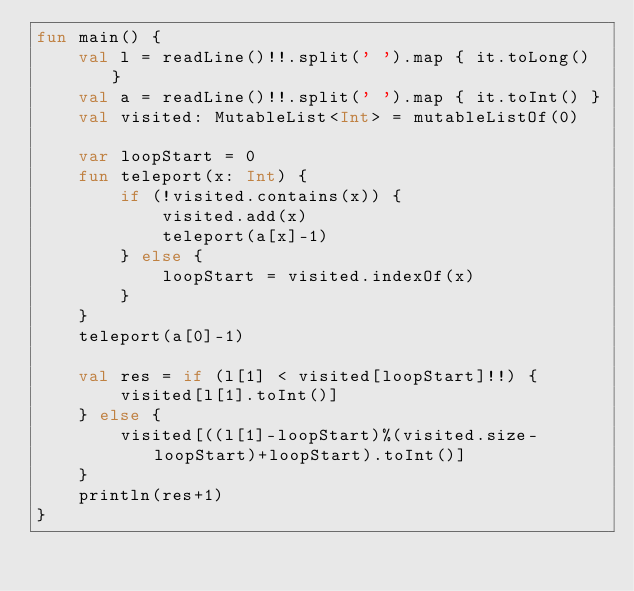<code> <loc_0><loc_0><loc_500><loc_500><_Kotlin_>fun main() {
    val l = readLine()!!.split(' ').map { it.toLong() }
    val a = readLine()!!.split(' ').map { it.toInt() }
    val visited: MutableList<Int> = mutableListOf(0)

    var loopStart = 0
    fun teleport(x: Int) {
        if (!visited.contains(x)) {
            visited.add(x)
            teleport(a[x]-1)
        } else {
            loopStart = visited.indexOf(x)
        }
    }
    teleport(a[0]-1)

    val res = if (l[1] < visited[loopStart]!!) {
        visited[l[1].toInt()]
    } else {
        visited[((l[1]-loopStart)%(visited.size-loopStart)+loopStart).toInt()]
    }
    println(res+1)
}
</code> 